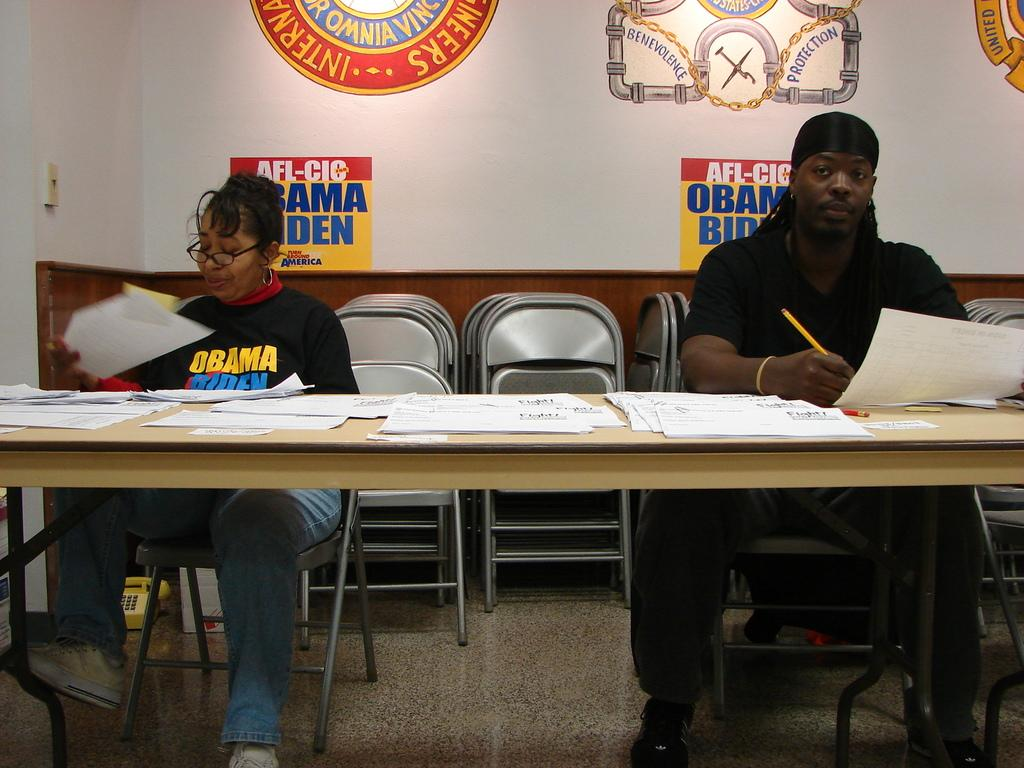How many people are sitting at the table in the image? There are two people sitting on the table in the image. What is on top of the table? Papers are on top of the table. What can be seen in the background of the image? There are posts attached to the wall in the background. What type of education can be seen being provided by the hand in the image? There is no hand present in the image, and therefore no education or learning activity can be observed. 